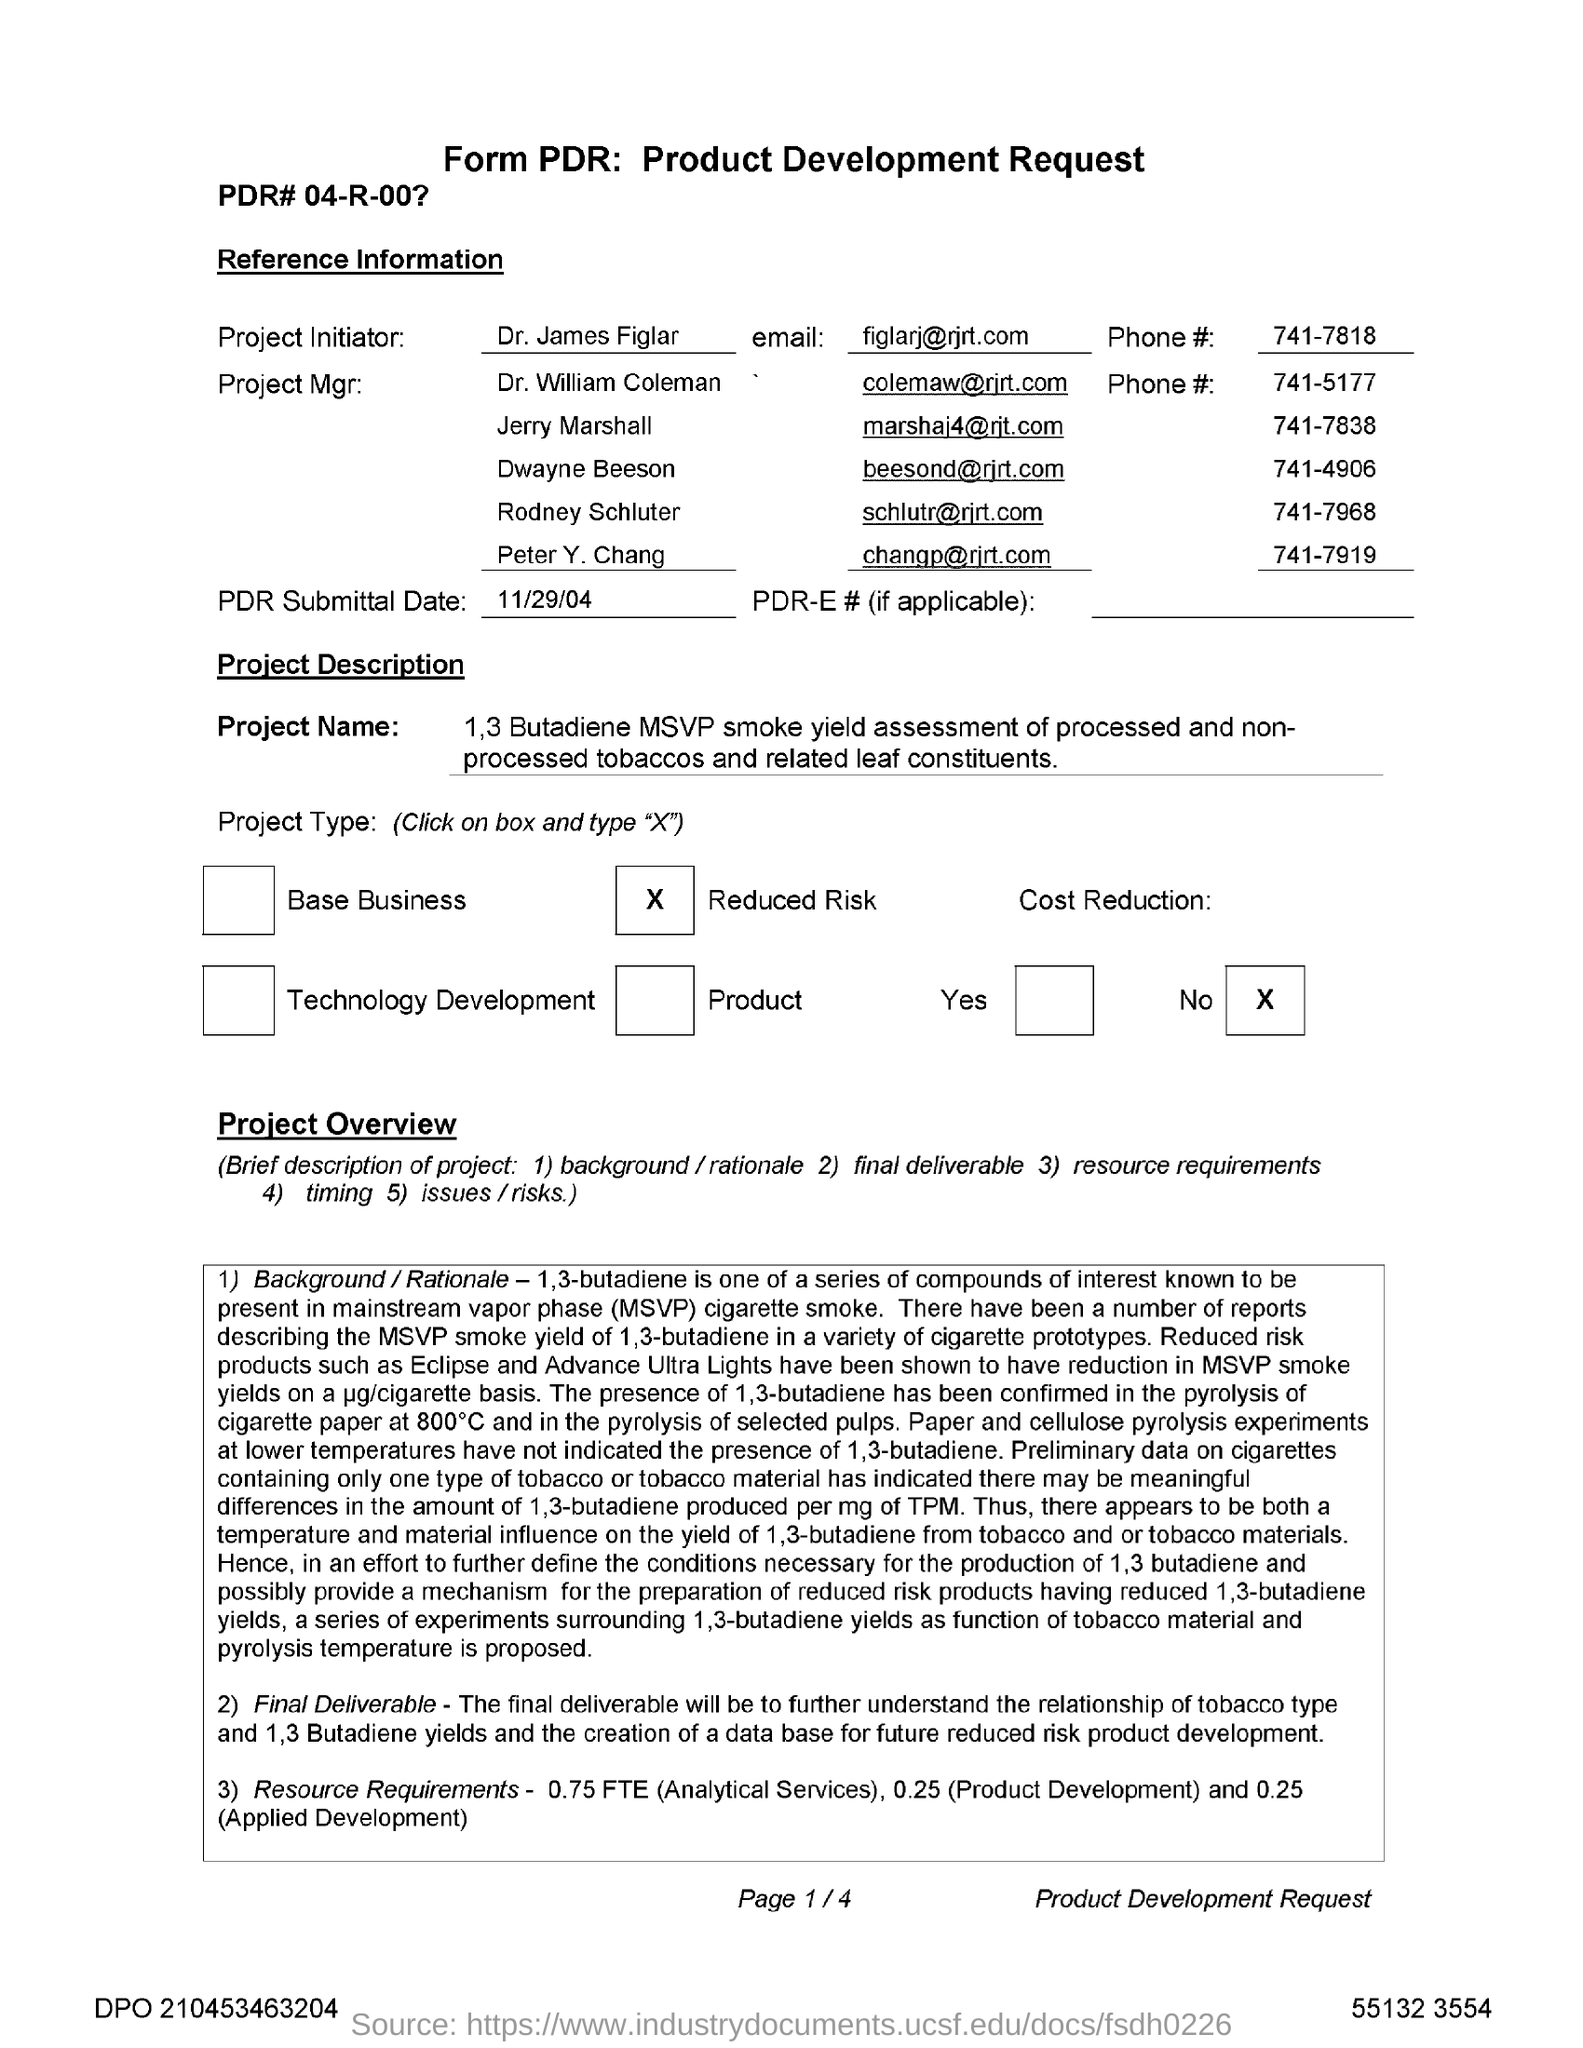Who is the Project Initiator?
Provide a succinct answer. Dr. James Figlar. What is the PDR Submittal Date?
Provide a short and direct response. 11/29/04. What is the email for Dr. James Figlar?
Offer a terse response. Figlarj@rjrt.com. What is the Phone # for Dr. James Figlar?
Your response must be concise. 741-7818. 